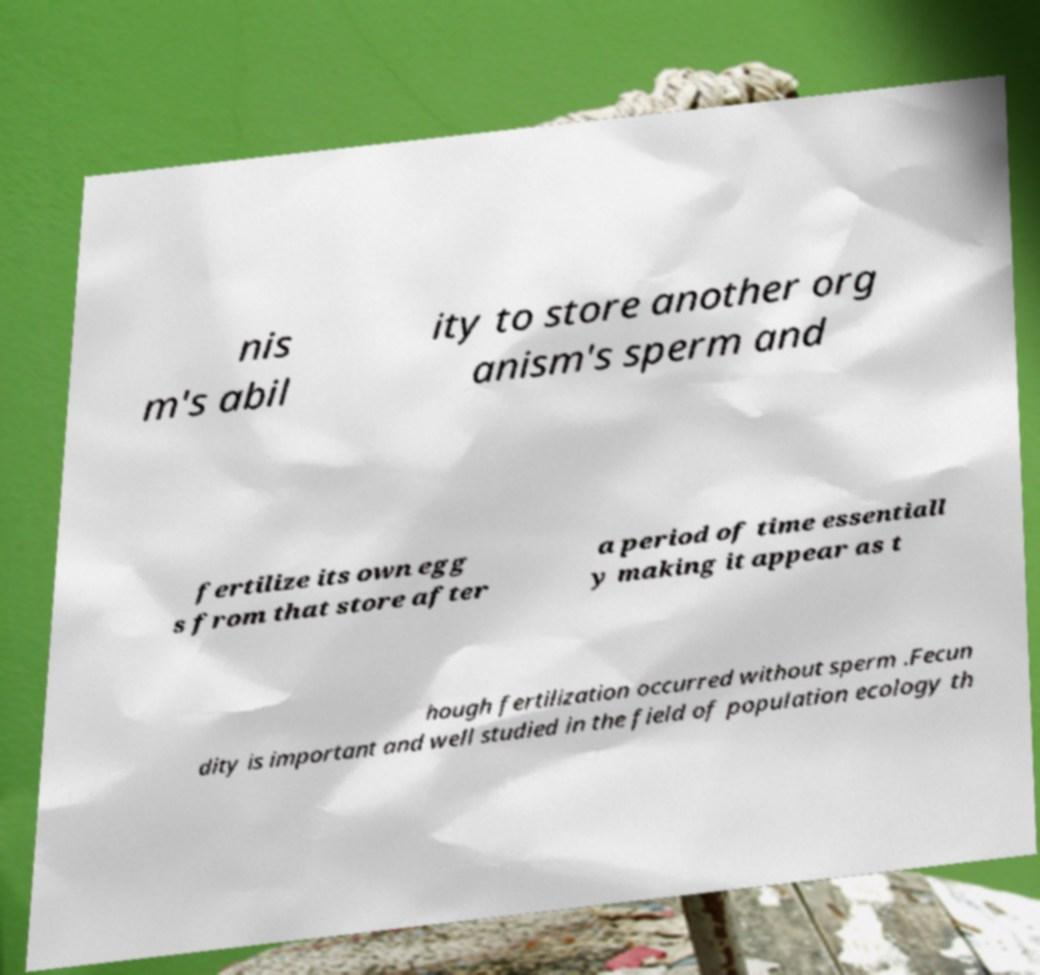Can you read and provide the text displayed in the image?This photo seems to have some interesting text. Can you extract and type it out for me? nis m's abil ity to store another org anism's sperm and fertilize its own egg s from that store after a period of time essentiall y making it appear as t hough fertilization occurred without sperm .Fecun dity is important and well studied in the field of population ecology th 